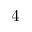<formula> <loc_0><loc_0><loc_500><loc_500>4</formula> 